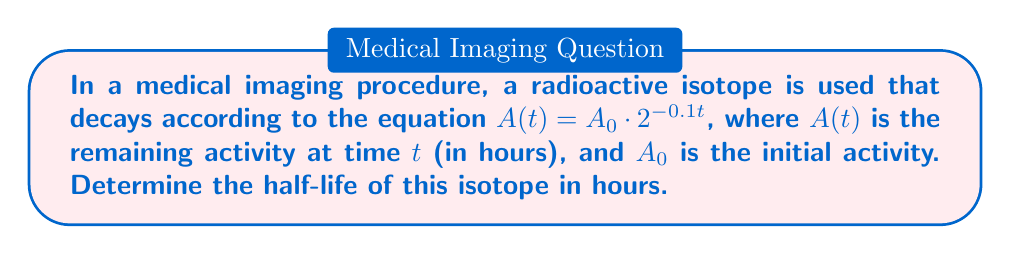Solve this math problem. To solve this problem, we'll follow these steps:

1) The half-life is the time it takes for the activity to reduce to half of its initial value. Mathematically, this means:

   $A(t_{1/2}) = \frac{1}{2}A_0$

2) We can substitute this into our decay equation:

   $\frac{1}{2}A_0 = A_0 \cdot 2^{-0.1t_{1/2}}$

3) The $A_0$ cancels out on both sides:

   $\frac{1}{2} = 2^{-0.1t_{1/2}}$

4) Now we can take the logarithm (base 2) of both sides:

   $\log_2(\frac{1}{2}) = \log_2(2^{-0.1t_{1/2}})$

5) The right side simplifies due to the logarithm rule $\log_a(a^x) = x$:

   $\log_2(\frac{1}{2}) = -0.1t_{1/2}$

6) We know that $\log_2(\frac{1}{2}) = -1$, so:

   $-1 = -0.1t_{1/2}$

7) Solving for $t_{1/2}$:

   $t_{1/2} = \frac{1}{0.1} = 10$

Therefore, the half-life of the isotope is 10 hours.
Answer: 10 hours 